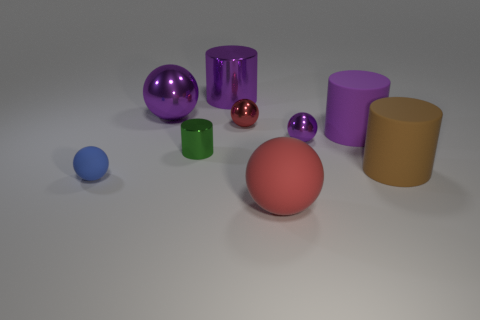Subtract all blue spheres. How many spheres are left? 4 Subtract all brown balls. Subtract all purple cubes. How many balls are left? 5 Add 1 small yellow cubes. How many objects exist? 10 Subtract all balls. How many objects are left? 4 Add 1 rubber balls. How many rubber balls exist? 3 Subtract 2 purple cylinders. How many objects are left? 7 Subtract all small blue matte balls. Subtract all brown matte things. How many objects are left? 7 Add 7 small rubber spheres. How many small rubber spheres are left? 8 